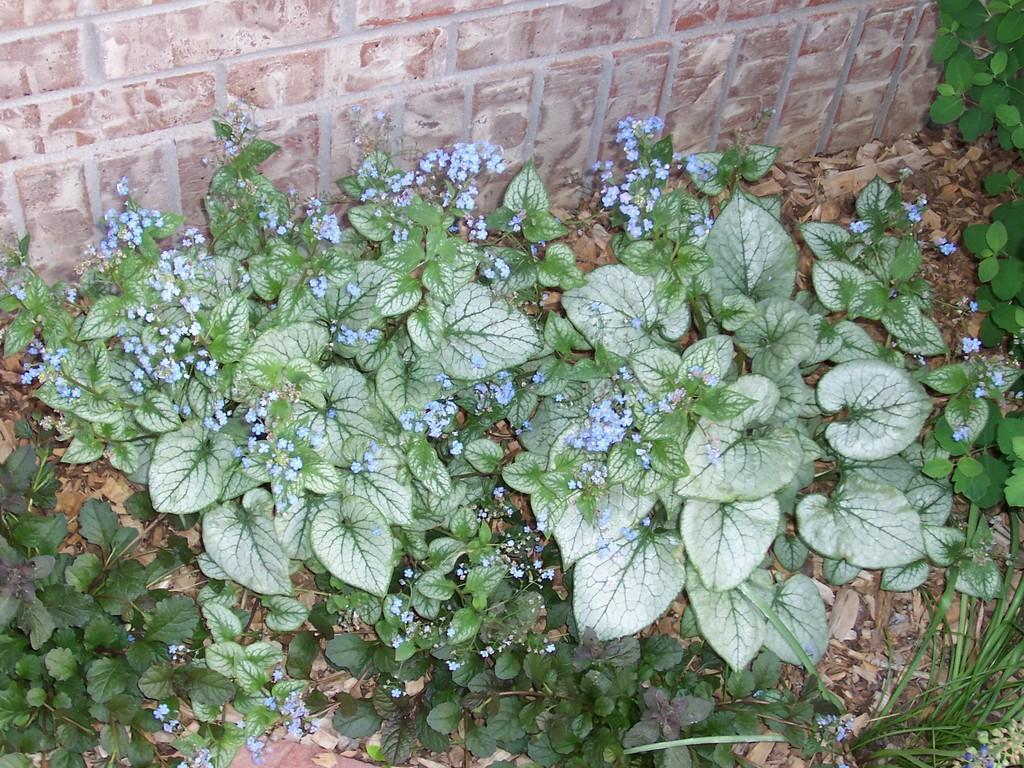Please provide a concise description of this image. In this picture there are some green plants on the ground. Behind there is a brown color granite wall. 